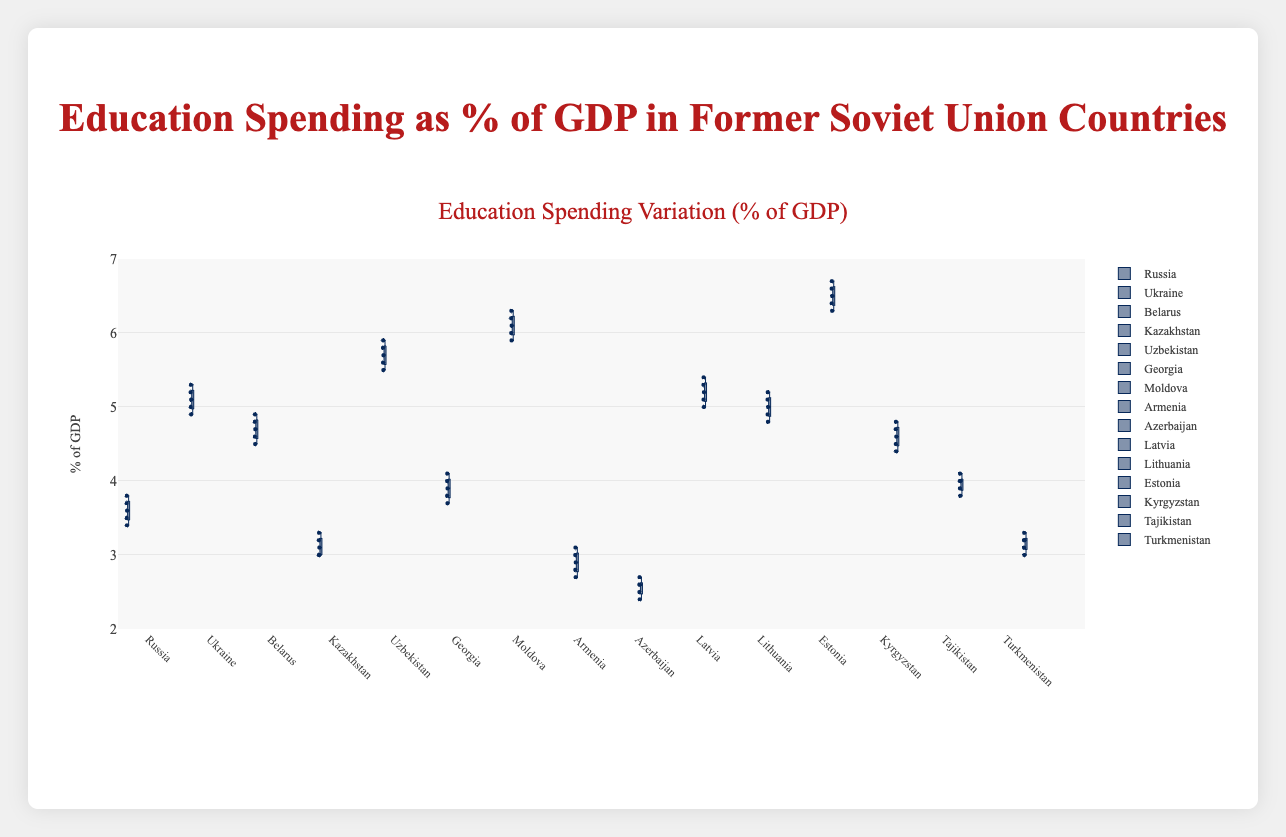What is the title of the box plot? The title of any graph is typically placed at the top center to introduce the main topic of the visualization. The title for this box plot is "Education Spending as % of GDP in Former Soviet Union Countries".
Answer: Education Spending as % of GDP in Former Soviet Union Countries Which country has the widest range of education spending as a percentage of GDP? To find the country with the widest range, identify the length of the box and whiskers. Estonia has the widest range, with the interquartile range (IQR) stretching from 6.3% to 6.7% and overall range (including whiskers) stretching approximately from 6.3% to 6.7%.
Answer: Estonia What country has the highest median value of education spending as a percentage of GDP? The median value in a box plot is denoted by the line inside the box. Moldova's median value is around 6.1%, which is the highest among all the countries shown.
Answer: Moldova What is the median education spending as a percentage of GDP for Belarus? Locate Belarus's box plot and identify the line inside the box which denotes the median. For Belarus, the median is approximately 4.7%.
Answer: 4.7% Which two countries have the closest median values of education spending as a percentage of GDP? Compare the lines inside the boxes of each box plot to find the closest medians. Lithuania and Latvia have very similar median values around 5.0% and 5.2%, respectively.
Answer: Lithuania and Latvia Which country has the lowest minimum value of education spending as a percentage of GDP? The minimum value in a box plot is represented by the bottom whisker. Azerbaijan has the lowest minimum value, around 2.4%.
Answer: Azerbaijan How does the variation in education spending in Estonia compare to that in Armenia? Compare both the range (distance between whiskers) and the interquartile range (box length) of the countries. Estonia has much higher variation (with a range from 6.3% to 6.7%) than Armenia (with a range from 2.7% to 3.1%).
Answer: Estonia has higher variation Which country has the smallest interquartile range (IQR) of education spending? IQR is the distance between the top and bottom edges of the box. Azerbaijan has the smallest IQR, indicating less variation, with the box and whiskers closely grouped from 2.4% to 2.7%.
Answer: Azerbaijan What is the 75th percentile of education spending as a percentage of GDP for Ukraine? The 75th percentile is represented by the top edge of the box. For Ukraine, the 75th percentile is approximately 5.2%.
Answer: 5.2% How does the upper whisker of Latvia's education spending compare to that of Lithuania’s? The upper whisker represents the maximum value excluding outliers. Compare the two whiskers directly. Latvia’s upper whisker is slightly higher than Lithuania's, with values around 5.4% and 5.2%, respectively.
Answer: Latvia's upper whisker is higher 